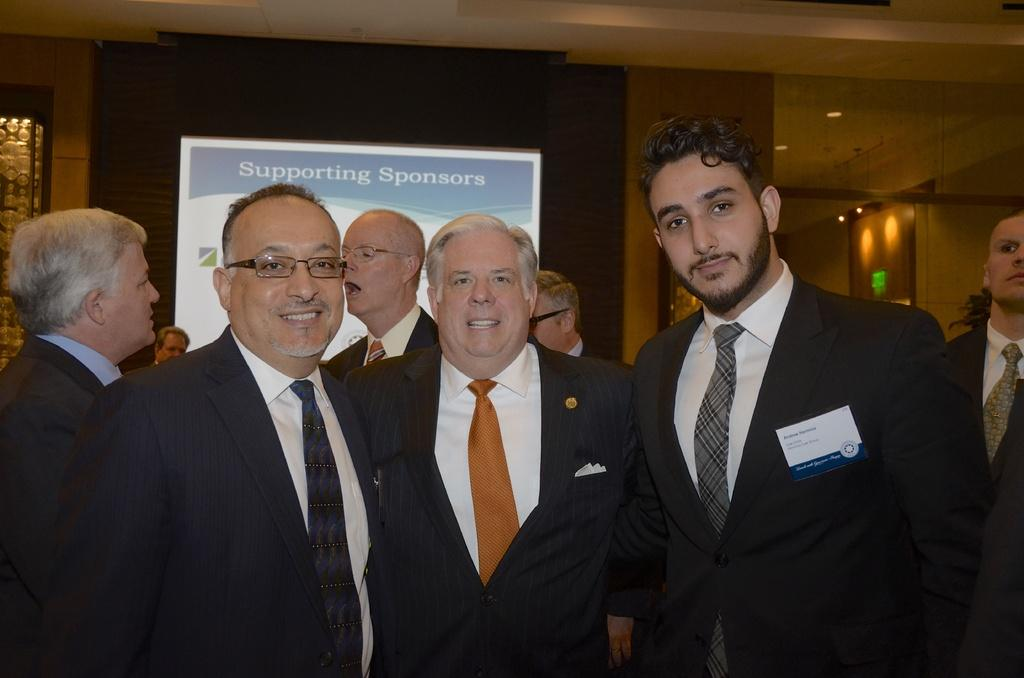How many people are in the image? There are three men in the image. What are the men doing in the image? The men are posing for a photograph. What can be seen in the background of the image? There are people walking and a banner in the background of the image. What type of winter clothing are the men wearing in the image? There is no mention of winter clothing or any specific season in the image, so it cannot be determined what type of clothing the men are wearing. 